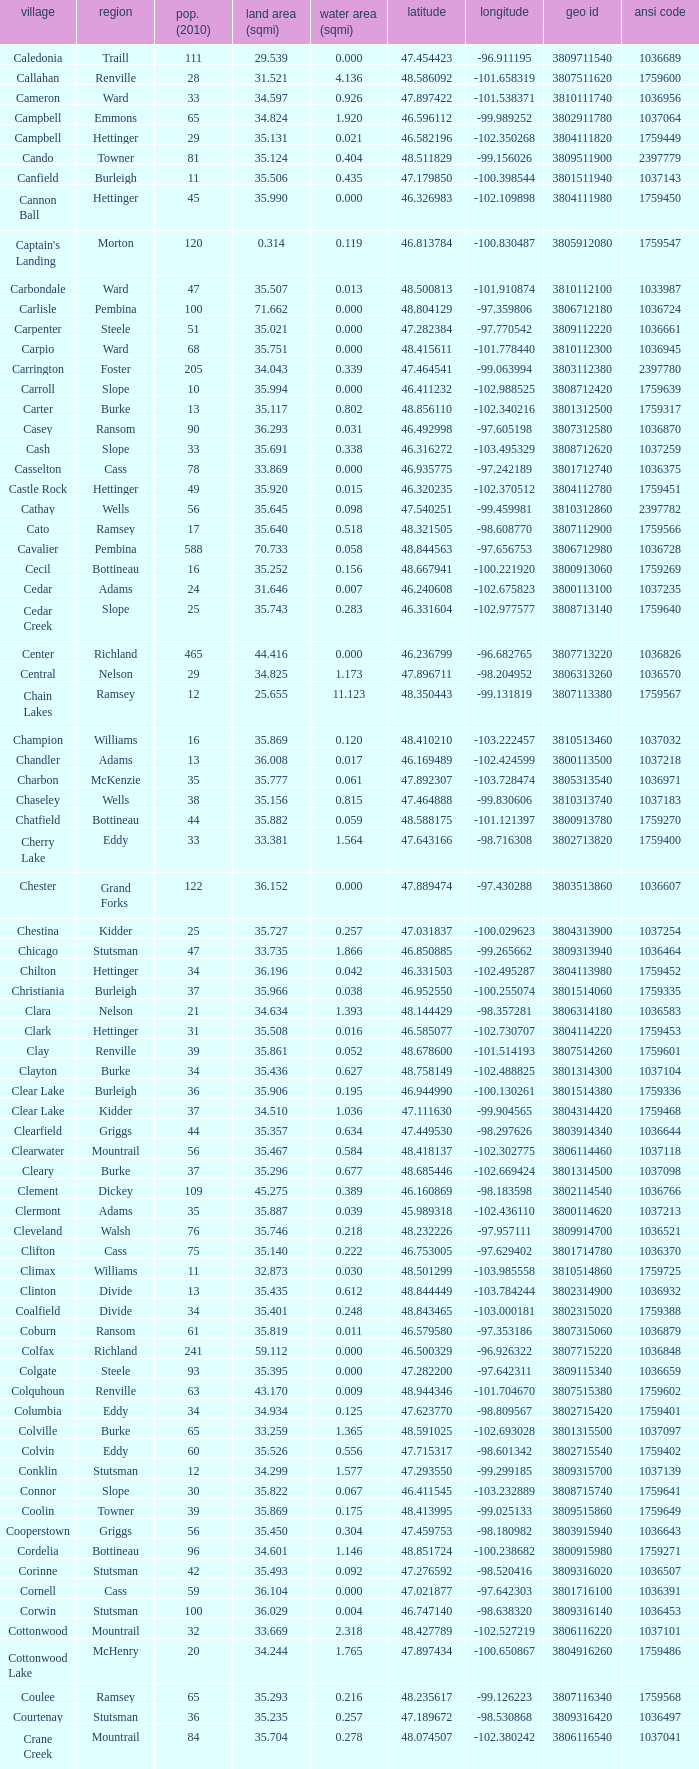What was the township with a geo ID of 3807116660? Creel. Give me the full table as a dictionary. {'header': ['village', 'region', 'pop. (2010)', 'land area (sqmi)', 'water area (sqmi)', 'latitude', 'longitude', 'geo id', 'ansi code'], 'rows': [['Caledonia', 'Traill', '111', '29.539', '0.000', '47.454423', '-96.911195', '3809711540', '1036689'], ['Callahan', 'Renville', '28', '31.521', '4.136', '48.586092', '-101.658319', '3807511620', '1759600'], ['Cameron', 'Ward', '33', '34.597', '0.926', '47.897422', '-101.538371', '3810111740', '1036956'], ['Campbell', 'Emmons', '65', '34.824', '1.920', '46.596112', '-99.989252', '3802911780', '1037064'], ['Campbell', 'Hettinger', '29', '35.131', '0.021', '46.582196', '-102.350268', '3804111820', '1759449'], ['Cando', 'Towner', '81', '35.124', '0.404', '48.511829', '-99.156026', '3809511900', '2397779'], ['Canfield', 'Burleigh', '11', '35.506', '0.435', '47.179850', '-100.398544', '3801511940', '1037143'], ['Cannon Ball', 'Hettinger', '45', '35.990', '0.000', '46.326983', '-102.109898', '3804111980', '1759450'], ["Captain's Landing", 'Morton', '120', '0.314', '0.119', '46.813784', '-100.830487', '3805912080', '1759547'], ['Carbondale', 'Ward', '47', '35.507', '0.013', '48.500813', '-101.910874', '3810112100', '1033987'], ['Carlisle', 'Pembina', '100', '71.662', '0.000', '48.804129', '-97.359806', '3806712180', '1036724'], ['Carpenter', 'Steele', '51', '35.021', '0.000', '47.282384', '-97.770542', '3809112220', '1036661'], ['Carpio', 'Ward', '68', '35.751', '0.000', '48.415611', '-101.778440', '3810112300', '1036945'], ['Carrington', 'Foster', '205', '34.043', '0.339', '47.464541', '-99.063994', '3803112380', '2397780'], ['Carroll', 'Slope', '10', '35.994', '0.000', '46.411232', '-102.988525', '3808712420', '1759639'], ['Carter', 'Burke', '13', '35.117', '0.802', '48.856110', '-102.340216', '3801312500', '1759317'], ['Casey', 'Ransom', '90', '36.293', '0.031', '46.492998', '-97.605198', '3807312580', '1036870'], ['Cash', 'Slope', '33', '35.691', '0.338', '46.316272', '-103.495329', '3808712620', '1037259'], ['Casselton', 'Cass', '78', '33.869', '0.000', '46.935775', '-97.242189', '3801712740', '1036375'], ['Castle Rock', 'Hettinger', '49', '35.920', '0.015', '46.320235', '-102.370512', '3804112780', '1759451'], ['Cathay', 'Wells', '56', '35.645', '0.098', '47.540251', '-99.459981', '3810312860', '2397782'], ['Cato', 'Ramsey', '17', '35.640', '0.518', '48.321505', '-98.608770', '3807112900', '1759566'], ['Cavalier', 'Pembina', '588', '70.733', '0.058', '48.844563', '-97.656753', '3806712980', '1036728'], ['Cecil', 'Bottineau', '16', '35.252', '0.156', '48.667941', '-100.221920', '3800913060', '1759269'], ['Cedar', 'Adams', '24', '31.646', '0.007', '46.240608', '-102.675823', '3800113100', '1037235'], ['Cedar Creek', 'Slope', '25', '35.743', '0.283', '46.331604', '-102.977577', '3808713140', '1759640'], ['Center', 'Richland', '465', '44.416', '0.000', '46.236799', '-96.682765', '3807713220', '1036826'], ['Central', 'Nelson', '29', '34.825', '1.173', '47.896711', '-98.204952', '3806313260', '1036570'], ['Chain Lakes', 'Ramsey', '12', '25.655', '11.123', '48.350443', '-99.131819', '3807113380', '1759567'], ['Champion', 'Williams', '16', '35.869', '0.120', '48.410210', '-103.222457', '3810513460', '1037032'], ['Chandler', 'Adams', '13', '36.008', '0.017', '46.169489', '-102.424599', '3800113500', '1037218'], ['Charbon', 'McKenzie', '35', '35.777', '0.061', '47.892307', '-103.728474', '3805313540', '1036971'], ['Chaseley', 'Wells', '38', '35.156', '0.815', '47.464888', '-99.830606', '3810313740', '1037183'], ['Chatfield', 'Bottineau', '44', '35.882', '0.059', '48.588175', '-101.121397', '3800913780', '1759270'], ['Cherry Lake', 'Eddy', '33', '33.381', '1.564', '47.643166', '-98.716308', '3802713820', '1759400'], ['Chester', 'Grand Forks', '122', '36.152', '0.000', '47.889474', '-97.430288', '3803513860', '1036607'], ['Chestina', 'Kidder', '25', '35.727', '0.257', '47.031837', '-100.029623', '3804313900', '1037254'], ['Chicago', 'Stutsman', '47', '33.735', '1.866', '46.850885', '-99.265662', '3809313940', '1036464'], ['Chilton', 'Hettinger', '34', '36.196', '0.042', '46.331503', '-102.495287', '3804113980', '1759452'], ['Christiania', 'Burleigh', '37', '35.966', '0.038', '46.952550', '-100.255074', '3801514060', '1759335'], ['Clara', 'Nelson', '21', '34.634', '1.393', '48.144429', '-98.357281', '3806314180', '1036583'], ['Clark', 'Hettinger', '31', '35.508', '0.016', '46.585077', '-102.730707', '3804114220', '1759453'], ['Clay', 'Renville', '39', '35.861', '0.052', '48.678600', '-101.514193', '3807514260', '1759601'], ['Clayton', 'Burke', '34', '35.436', '0.627', '48.758149', '-102.488825', '3801314300', '1037104'], ['Clear Lake', 'Burleigh', '36', '35.906', '0.195', '46.944990', '-100.130261', '3801514380', '1759336'], ['Clear Lake', 'Kidder', '37', '34.510', '1.036', '47.111630', '-99.904565', '3804314420', '1759468'], ['Clearfield', 'Griggs', '44', '35.357', '0.634', '47.449530', '-98.297626', '3803914340', '1036644'], ['Clearwater', 'Mountrail', '56', '35.467', '0.584', '48.418137', '-102.302775', '3806114460', '1037118'], ['Cleary', 'Burke', '37', '35.296', '0.677', '48.685446', '-102.669424', '3801314500', '1037098'], ['Clement', 'Dickey', '109', '45.275', '0.389', '46.160869', '-98.183598', '3802114540', '1036766'], ['Clermont', 'Adams', '35', '35.887', '0.039', '45.989318', '-102.436110', '3800114620', '1037213'], ['Cleveland', 'Walsh', '76', '35.746', '0.218', '48.232226', '-97.957111', '3809914700', '1036521'], ['Clifton', 'Cass', '75', '35.140', '0.222', '46.753005', '-97.629402', '3801714780', '1036370'], ['Climax', 'Williams', '11', '32.873', '0.030', '48.501299', '-103.985558', '3810514860', '1759725'], ['Clinton', 'Divide', '13', '35.435', '0.612', '48.844449', '-103.784244', '3802314900', '1036932'], ['Coalfield', 'Divide', '34', '35.401', '0.248', '48.843465', '-103.000181', '3802315020', '1759388'], ['Coburn', 'Ransom', '61', '35.819', '0.011', '46.579580', '-97.353186', '3807315060', '1036879'], ['Colfax', 'Richland', '241', '59.112', '0.000', '46.500329', '-96.926322', '3807715220', '1036848'], ['Colgate', 'Steele', '93', '35.395', '0.000', '47.282200', '-97.642311', '3809115340', '1036659'], ['Colquhoun', 'Renville', '63', '43.170', '0.009', '48.944346', '-101.704670', '3807515380', '1759602'], ['Columbia', 'Eddy', '34', '34.934', '0.125', '47.623770', '-98.809567', '3802715420', '1759401'], ['Colville', 'Burke', '65', '33.259', '1.365', '48.591025', '-102.693028', '3801315500', '1037097'], ['Colvin', 'Eddy', '60', '35.526', '0.556', '47.715317', '-98.601342', '3802715540', '1759402'], ['Conklin', 'Stutsman', '12', '34.299', '1.577', '47.293550', '-99.299185', '3809315700', '1037139'], ['Connor', 'Slope', '30', '35.822', '0.067', '46.411545', '-103.232889', '3808715740', '1759641'], ['Coolin', 'Towner', '39', '35.869', '0.175', '48.413995', '-99.025133', '3809515860', '1759649'], ['Cooperstown', 'Griggs', '56', '35.450', '0.304', '47.459753', '-98.180982', '3803915940', '1036643'], ['Cordelia', 'Bottineau', '96', '34.601', '1.146', '48.851724', '-100.238682', '3800915980', '1759271'], ['Corinne', 'Stutsman', '42', '35.493', '0.092', '47.276592', '-98.520416', '3809316020', '1036507'], ['Cornell', 'Cass', '59', '36.104', '0.000', '47.021877', '-97.642303', '3801716100', '1036391'], ['Corwin', 'Stutsman', '100', '36.029', '0.004', '46.747140', '-98.638320', '3809316140', '1036453'], ['Cottonwood', 'Mountrail', '32', '33.669', '2.318', '48.427789', '-102.527219', '3806116220', '1037101'], ['Cottonwood Lake', 'McHenry', '20', '34.244', '1.765', '47.897434', '-100.650867', '3804916260', '1759486'], ['Coulee', 'Ramsey', '65', '35.293', '0.216', '48.235617', '-99.126223', '3807116340', '1759568'], ['Courtenay', 'Stutsman', '36', '35.235', '0.257', '47.189672', '-98.530868', '3809316420', '1036497'], ['Crane Creek', 'Mountrail', '84', '35.704', '0.278', '48.074507', '-102.380242', '3806116540', '1037041'], ['Crawford', 'Slope', '31', '35.892', '0.051', '46.320329', '-103.729934', '3808716620', '1037166'], ['Creel', 'Ramsey', '1305', '14.578', '15.621', '48.075823', '-98.857272', '3807116660', '1759569'], ['Cremerville', 'McLean', '27', '35.739', '0.054', '47.811011', '-102.054883', '3805516700', '1759530'], ['Crocus', 'Towner', '44', '35.047', '0.940', '48.667289', '-99.155787', '3809516820', '1759650'], ['Crofte', 'Burleigh', '199', '36.163', '0.000', '47.026425', '-100.685988', '3801516860', '1037131'], ['Cromwell', 'Burleigh', '35', '36.208', '0.000', '47.026008', '-100.558805', '3801516900', '1037133'], ['Crowfoot', 'Mountrail', '18', '34.701', '1.283', '48.495946', '-102.180433', '3806116980', '1037050'], ['Crown Hill', 'Kidder', '7', '30.799', '1.468', '46.770977', '-100.025924', '3804317020', '1759469'], ['Crystal', 'Pembina', '50', '35.499', '0.000', '48.586423', '-97.732145', '3806717100', '1036718'], ['Crystal Lake', 'Wells', '32', '35.522', '0.424', '47.541346', '-99.974737', '3810317140', '1037152'], ['Crystal Springs', 'Kidder', '32', '35.415', '0.636', '46.848792', '-99.529639', '3804317220', '1759470'], ['Cuba', 'Barnes', '76', '35.709', '0.032', '46.851144', '-97.860271', '3800317300', '1036409'], ['Cusator', 'Stutsman', '26', '34.878', '0.693', '46.746853', '-98.997611', '3809317460', '1036459'], ['Cut Bank', 'Bottineau', '37', '35.898', '0.033', '48.763937', '-101.430571', '3800917540', '1759272']]} 